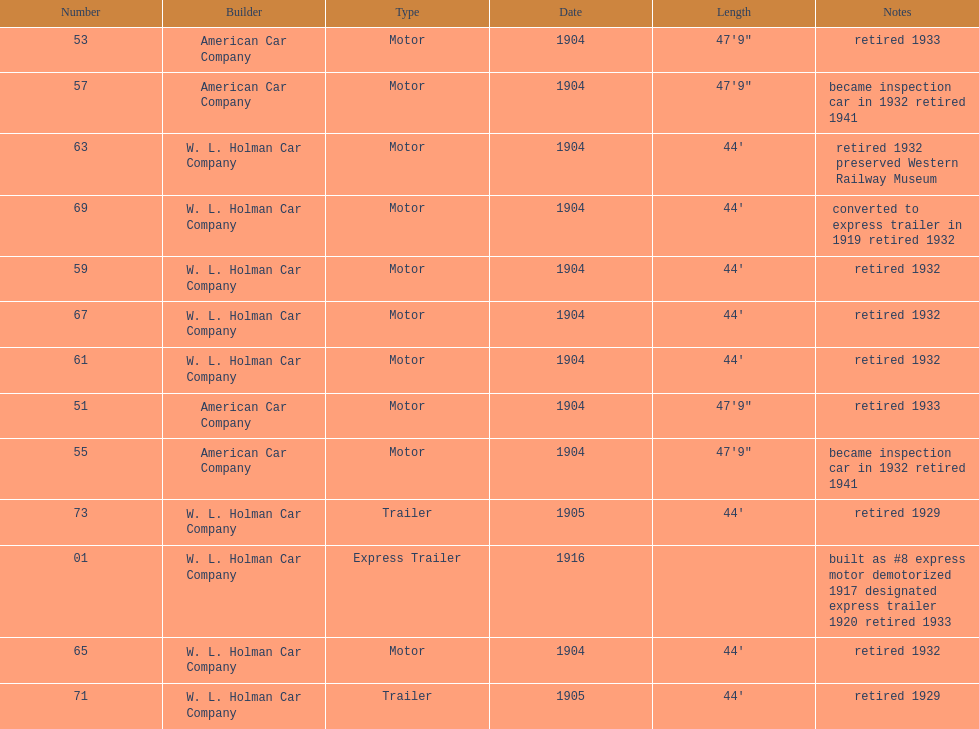What was the total number of cars listed? 13. 